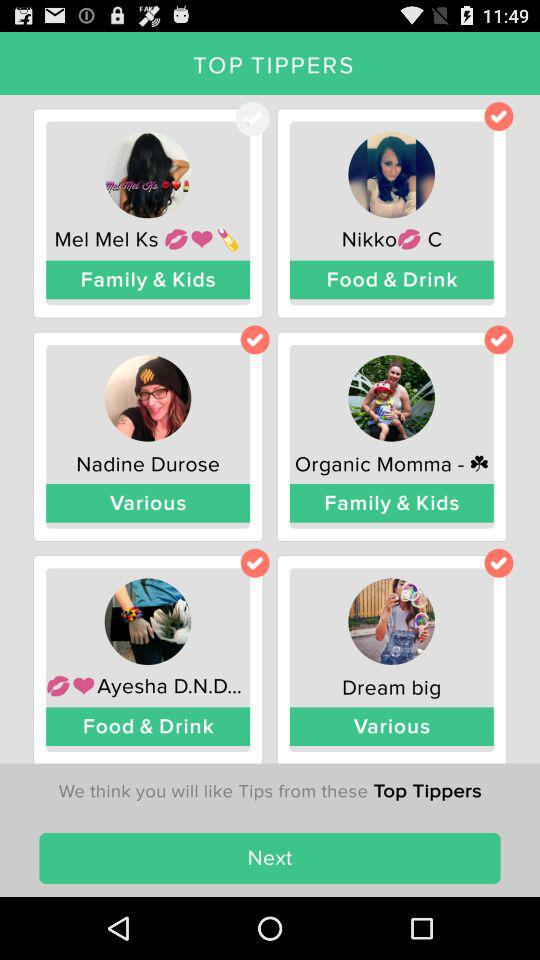What's the checked status of Mel Mel Ks? The checked status is "off". 